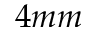Convert formula to latex. <formula><loc_0><loc_0><loc_500><loc_500>4 m m</formula> 